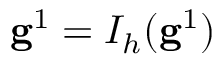Convert formula to latex. <formula><loc_0><loc_0><loc_500><loc_500>g ^ { 1 } = I _ { h } ( g ^ { 1 } )</formula> 